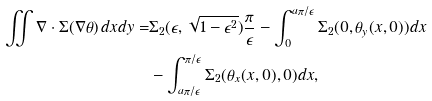Convert formula to latex. <formula><loc_0><loc_0><loc_500><loc_500>\iint \nabla \cdot \Sigma ( \nabla \theta ) \, d x d y = & \Sigma _ { 2 } ( \epsilon , \sqrt { 1 - \epsilon ^ { 2 } } ) \frac { \pi } { \epsilon } - \int _ { 0 } ^ { a \pi / \epsilon } \Sigma _ { 2 } ( 0 , \theta _ { y } ( x , 0 ) ) d x \\ & - \int _ { a \pi / \epsilon } ^ { \pi / \epsilon } \Sigma _ { 2 } ( \theta _ { x } ( x , 0 ) , 0 ) d x ,</formula> 